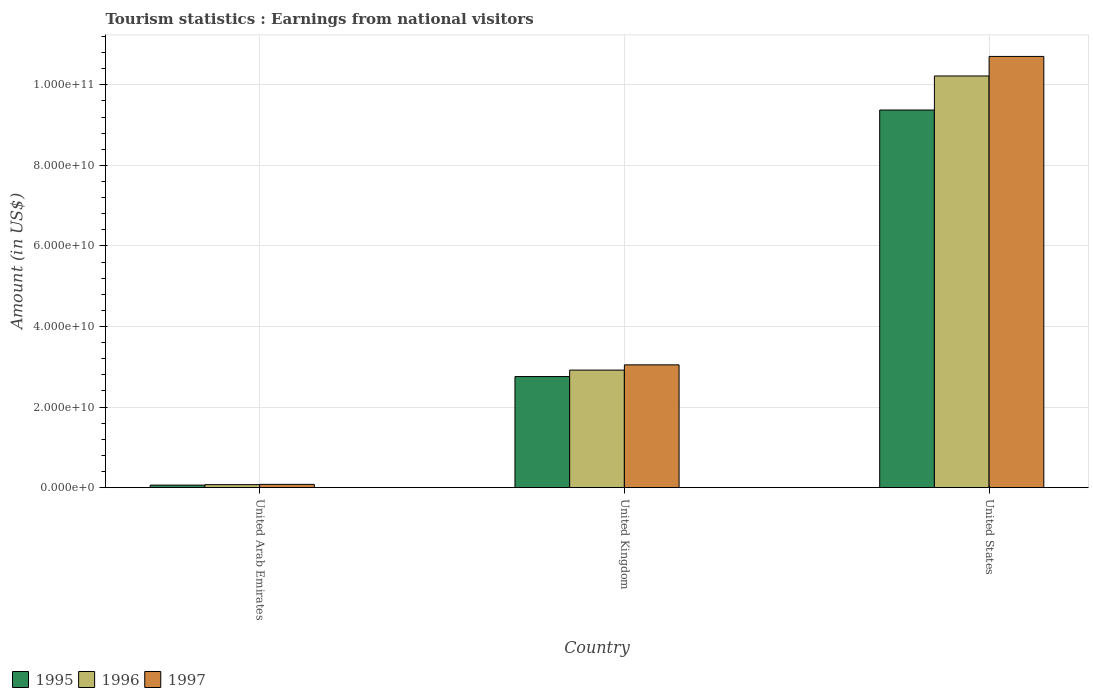How many different coloured bars are there?
Your answer should be compact. 3. How many bars are there on the 3rd tick from the left?
Your answer should be compact. 3. What is the label of the 1st group of bars from the left?
Your answer should be compact. United Arab Emirates. What is the earnings from national visitors in 1997 in United States?
Ensure brevity in your answer.  1.07e+11. Across all countries, what is the maximum earnings from national visitors in 1997?
Your answer should be compact. 1.07e+11. Across all countries, what is the minimum earnings from national visitors in 1995?
Provide a succinct answer. 6.32e+08. In which country was the earnings from national visitors in 1996 maximum?
Provide a short and direct response. United States. In which country was the earnings from national visitors in 1995 minimum?
Your response must be concise. United Arab Emirates. What is the total earnings from national visitors in 1995 in the graph?
Offer a very short reply. 1.22e+11. What is the difference between the earnings from national visitors in 1995 in United Arab Emirates and that in United Kingdom?
Ensure brevity in your answer.  -2.69e+1. What is the difference between the earnings from national visitors in 1995 in United Arab Emirates and the earnings from national visitors in 1996 in United States?
Offer a very short reply. -1.02e+11. What is the average earnings from national visitors in 1997 per country?
Your response must be concise. 4.61e+1. What is the difference between the earnings from national visitors of/in 1997 and earnings from national visitors of/in 1996 in United Arab Emirates?
Offer a very short reply. 7.10e+07. What is the ratio of the earnings from national visitors in 1997 in United Arab Emirates to that in United Kingdom?
Give a very brief answer. 0.03. What is the difference between the highest and the second highest earnings from national visitors in 1997?
Provide a succinct answer. 1.06e+11. What is the difference between the highest and the lowest earnings from national visitors in 1996?
Provide a short and direct response. 1.01e+11. Is the sum of the earnings from national visitors in 1997 in United Arab Emirates and United States greater than the maximum earnings from national visitors in 1995 across all countries?
Your answer should be compact. Yes. Is it the case that in every country, the sum of the earnings from national visitors in 1995 and earnings from national visitors in 1996 is greater than the earnings from national visitors in 1997?
Provide a short and direct response. Yes. How many bars are there?
Your answer should be compact. 9. Are all the bars in the graph horizontal?
Your answer should be very brief. No. Does the graph contain any zero values?
Give a very brief answer. No. Where does the legend appear in the graph?
Your response must be concise. Bottom left. How are the legend labels stacked?
Provide a short and direct response. Horizontal. What is the title of the graph?
Keep it short and to the point. Tourism statistics : Earnings from national visitors. Does "2006" appear as one of the legend labels in the graph?
Provide a succinct answer. No. What is the label or title of the X-axis?
Ensure brevity in your answer.  Country. What is the label or title of the Y-axis?
Keep it short and to the point. Amount (in US$). What is the Amount (in US$) in 1995 in United Arab Emirates?
Your response must be concise. 6.32e+08. What is the Amount (in US$) of 1996 in United Arab Emirates?
Your answer should be very brief. 7.43e+08. What is the Amount (in US$) of 1997 in United Arab Emirates?
Your answer should be very brief. 8.14e+08. What is the Amount (in US$) in 1995 in United Kingdom?
Offer a terse response. 2.76e+1. What is the Amount (in US$) of 1996 in United Kingdom?
Your answer should be very brief. 2.92e+1. What is the Amount (in US$) in 1997 in United Kingdom?
Give a very brief answer. 3.05e+1. What is the Amount (in US$) of 1995 in United States?
Provide a succinct answer. 9.37e+1. What is the Amount (in US$) in 1996 in United States?
Make the answer very short. 1.02e+11. What is the Amount (in US$) in 1997 in United States?
Make the answer very short. 1.07e+11. Across all countries, what is the maximum Amount (in US$) of 1995?
Offer a terse response. 9.37e+1. Across all countries, what is the maximum Amount (in US$) in 1996?
Make the answer very short. 1.02e+11. Across all countries, what is the maximum Amount (in US$) in 1997?
Keep it short and to the point. 1.07e+11. Across all countries, what is the minimum Amount (in US$) in 1995?
Ensure brevity in your answer.  6.32e+08. Across all countries, what is the minimum Amount (in US$) in 1996?
Make the answer very short. 7.43e+08. Across all countries, what is the minimum Amount (in US$) in 1997?
Give a very brief answer. 8.14e+08. What is the total Amount (in US$) of 1995 in the graph?
Keep it short and to the point. 1.22e+11. What is the total Amount (in US$) in 1996 in the graph?
Your answer should be compact. 1.32e+11. What is the total Amount (in US$) of 1997 in the graph?
Provide a short and direct response. 1.38e+11. What is the difference between the Amount (in US$) of 1995 in United Arab Emirates and that in United Kingdom?
Offer a terse response. -2.69e+1. What is the difference between the Amount (in US$) in 1996 in United Arab Emirates and that in United Kingdom?
Provide a succinct answer. -2.84e+1. What is the difference between the Amount (in US$) in 1997 in United Arab Emirates and that in United Kingdom?
Give a very brief answer. -2.97e+1. What is the difference between the Amount (in US$) in 1995 in United Arab Emirates and that in United States?
Provide a short and direct response. -9.31e+1. What is the difference between the Amount (in US$) in 1996 in United Arab Emirates and that in United States?
Your answer should be very brief. -1.01e+11. What is the difference between the Amount (in US$) in 1997 in United Arab Emirates and that in United States?
Make the answer very short. -1.06e+11. What is the difference between the Amount (in US$) of 1995 in United Kingdom and that in United States?
Provide a short and direct response. -6.62e+1. What is the difference between the Amount (in US$) in 1996 in United Kingdom and that in United States?
Make the answer very short. -7.30e+1. What is the difference between the Amount (in US$) in 1997 in United Kingdom and that in United States?
Provide a succinct answer. -7.66e+1. What is the difference between the Amount (in US$) in 1995 in United Arab Emirates and the Amount (in US$) in 1996 in United Kingdom?
Provide a short and direct response. -2.85e+1. What is the difference between the Amount (in US$) in 1995 in United Arab Emirates and the Amount (in US$) in 1997 in United Kingdom?
Make the answer very short. -2.99e+1. What is the difference between the Amount (in US$) in 1996 in United Arab Emirates and the Amount (in US$) in 1997 in United Kingdom?
Offer a terse response. -2.97e+1. What is the difference between the Amount (in US$) of 1995 in United Arab Emirates and the Amount (in US$) of 1996 in United States?
Make the answer very short. -1.02e+11. What is the difference between the Amount (in US$) of 1995 in United Arab Emirates and the Amount (in US$) of 1997 in United States?
Provide a succinct answer. -1.06e+11. What is the difference between the Amount (in US$) in 1996 in United Arab Emirates and the Amount (in US$) in 1997 in United States?
Your response must be concise. -1.06e+11. What is the difference between the Amount (in US$) of 1995 in United Kingdom and the Amount (in US$) of 1996 in United States?
Ensure brevity in your answer.  -7.46e+1. What is the difference between the Amount (in US$) of 1995 in United Kingdom and the Amount (in US$) of 1997 in United States?
Provide a succinct answer. -7.95e+1. What is the difference between the Amount (in US$) of 1996 in United Kingdom and the Amount (in US$) of 1997 in United States?
Make the answer very short. -7.79e+1. What is the average Amount (in US$) in 1995 per country?
Give a very brief answer. 4.07e+1. What is the average Amount (in US$) in 1996 per country?
Give a very brief answer. 4.40e+1. What is the average Amount (in US$) in 1997 per country?
Offer a very short reply. 4.61e+1. What is the difference between the Amount (in US$) in 1995 and Amount (in US$) in 1996 in United Arab Emirates?
Your response must be concise. -1.11e+08. What is the difference between the Amount (in US$) of 1995 and Amount (in US$) of 1997 in United Arab Emirates?
Provide a succinct answer. -1.82e+08. What is the difference between the Amount (in US$) of 1996 and Amount (in US$) of 1997 in United Arab Emirates?
Your answer should be compact. -7.10e+07. What is the difference between the Amount (in US$) in 1995 and Amount (in US$) in 1996 in United Kingdom?
Offer a very short reply. -1.60e+09. What is the difference between the Amount (in US$) in 1995 and Amount (in US$) in 1997 in United Kingdom?
Make the answer very short. -2.91e+09. What is the difference between the Amount (in US$) in 1996 and Amount (in US$) in 1997 in United Kingdom?
Your answer should be very brief. -1.30e+09. What is the difference between the Amount (in US$) in 1995 and Amount (in US$) in 1996 in United States?
Give a very brief answer. -8.45e+09. What is the difference between the Amount (in US$) of 1995 and Amount (in US$) of 1997 in United States?
Your answer should be very brief. -1.33e+1. What is the difference between the Amount (in US$) of 1996 and Amount (in US$) of 1997 in United States?
Give a very brief answer. -4.85e+09. What is the ratio of the Amount (in US$) in 1995 in United Arab Emirates to that in United Kingdom?
Ensure brevity in your answer.  0.02. What is the ratio of the Amount (in US$) of 1996 in United Arab Emirates to that in United Kingdom?
Provide a short and direct response. 0.03. What is the ratio of the Amount (in US$) of 1997 in United Arab Emirates to that in United Kingdom?
Give a very brief answer. 0.03. What is the ratio of the Amount (in US$) in 1995 in United Arab Emirates to that in United States?
Provide a short and direct response. 0.01. What is the ratio of the Amount (in US$) in 1996 in United Arab Emirates to that in United States?
Ensure brevity in your answer.  0.01. What is the ratio of the Amount (in US$) of 1997 in United Arab Emirates to that in United States?
Give a very brief answer. 0.01. What is the ratio of the Amount (in US$) of 1995 in United Kingdom to that in United States?
Ensure brevity in your answer.  0.29. What is the ratio of the Amount (in US$) of 1996 in United Kingdom to that in United States?
Give a very brief answer. 0.29. What is the ratio of the Amount (in US$) in 1997 in United Kingdom to that in United States?
Keep it short and to the point. 0.28. What is the difference between the highest and the second highest Amount (in US$) in 1995?
Make the answer very short. 6.62e+1. What is the difference between the highest and the second highest Amount (in US$) in 1996?
Make the answer very short. 7.30e+1. What is the difference between the highest and the second highest Amount (in US$) of 1997?
Keep it short and to the point. 7.66e+1. What is the difference between the highest and the lowest Amount (in US$) of 1995?
Give a very brief answer. 9.31e+1. What is the difference between the highest and the lowest Amount (in US$) of 1996?
Offer a very short reply. 1.01e+11. What is the difference between the highest and the lowest Amount (in US$) of 1997?
Your answer should be compact. 1.06e+11. 